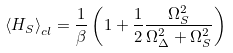Convert formula to latex. <formula><loc_0><loc_0><loc_500><loc_500>\left \langle H _ { S } \right \rangle _ { c l } = \frac { 1 } { \beta } \left ( 1 + \frac { 1 } { 2 } \frac { \Omega _ { S } ^ { 2 } } { \Omega _ { \Delta } ^ { 2 } + \Omega _ { S } ^ { 2 } } \right )</formula> 